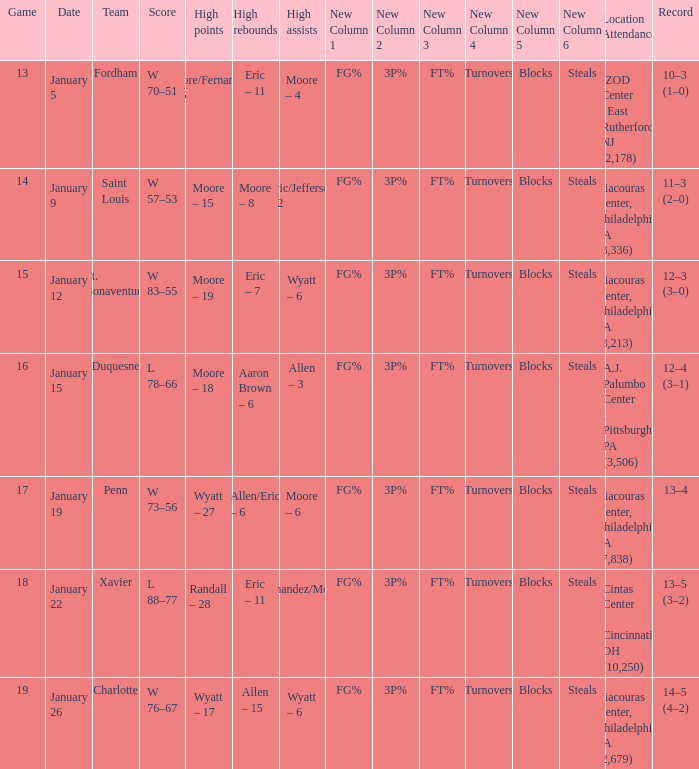Who had the most assists and how many did they have on January 5? Moore – 4. 